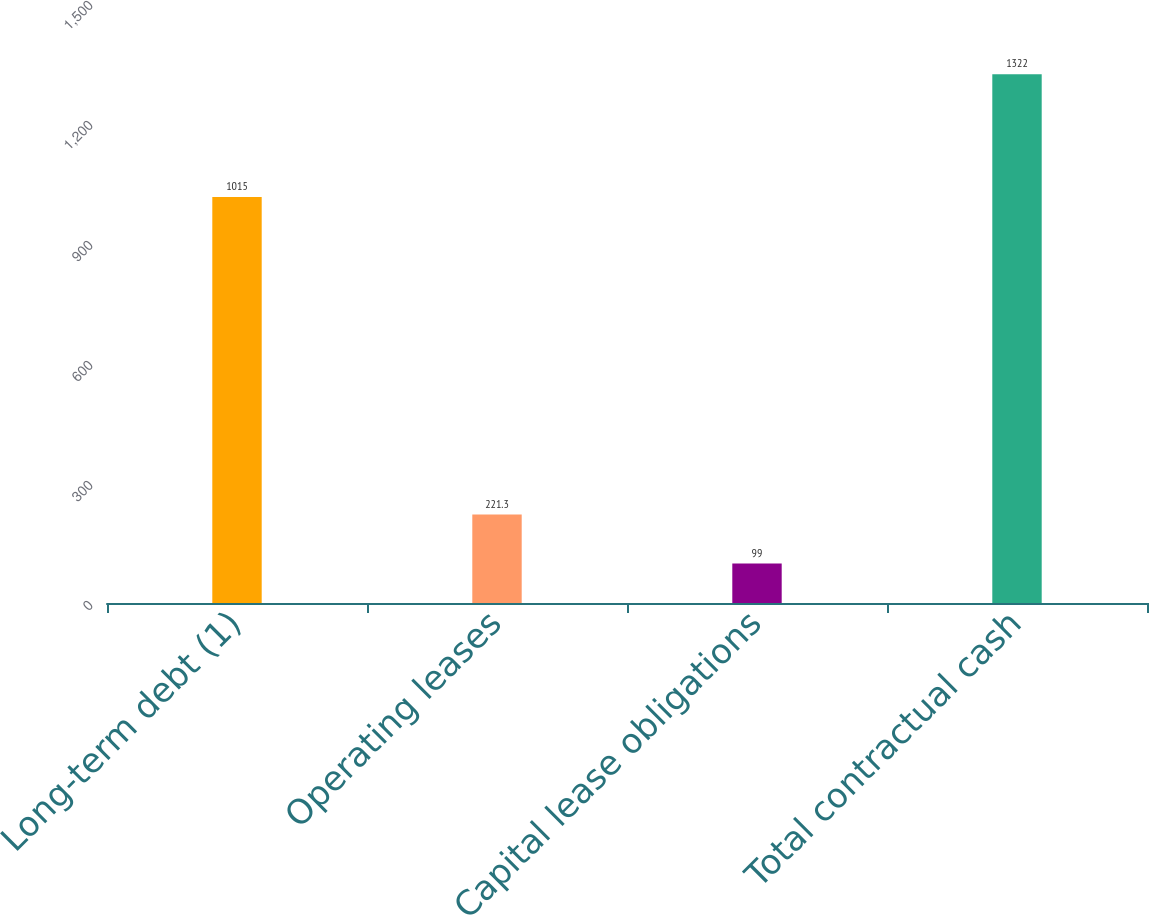<chart> <loc_0><loc_0><loc_500><loc_500><bar_chart><fcel>Long-term debt (1)<fcel>Operating leases<fcel>Capital lease obligations<fcel>Total contractual cash<nl><fcel>1015<fcel>221.3<fcel>99<fcel>1322<nl></chart> 